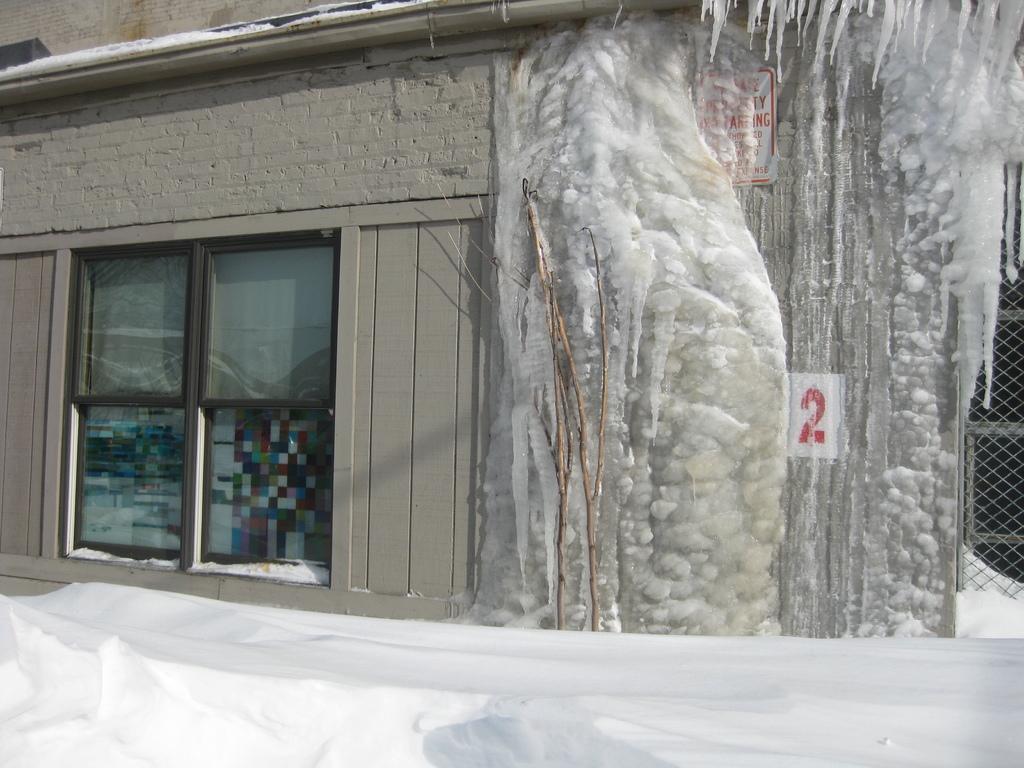Please provide a concise description of this image. There is a snow wall, near a building, which is having glass windows and on which, there is snow, near a fencing. 